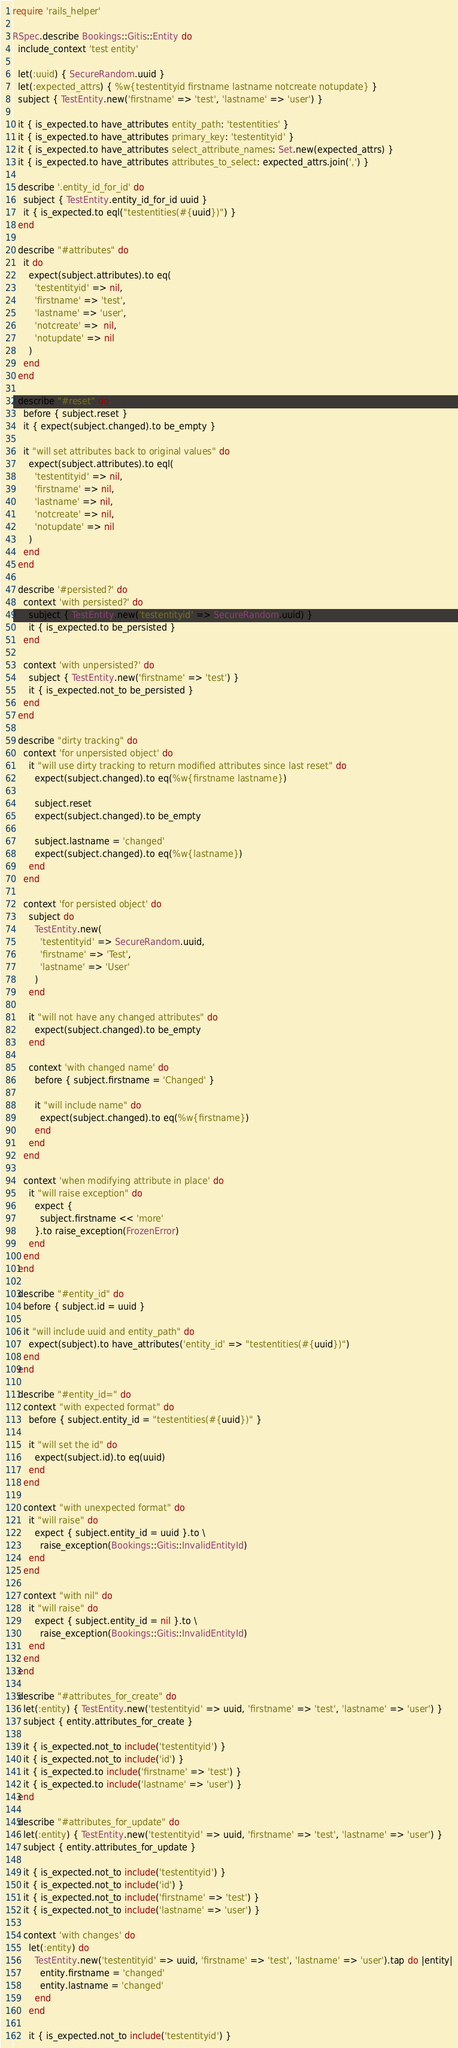Convert code to text. <code><loc_0><loc_0><loc_500><loc_500><_Ruby_>require 'rails_helper'

RSpec.describe Bookings::Gitis::Entity do
  include_context 'test entity'

  let(:uuid) { SecureRandom.uuid }
  let(:expected_attrs) { %w{testentityid firstname lastname notcreate notupdate} }
  subject { TestEntity.new('firstname' => 'test', 'lastname' => 'user') }

  it { is_expected.to have_attributes entity_path: 'testentities' }
  it { is_expected.to have_attributes primary_key: 'testentityid' }
  it { is_expected.to have_attributes select_attribute_names: Set.new(expected_attrs) }
  it { is_expected.to have_attributes attributes_to_select: expected_attrs.join(',') }

  describe '.entity_id_for_id' do
    subject { TestEntity.entity_id_for_id uuid }
    it { is_expected.to eql("testentities(#{uuid})") }
  end

  describe "#attributes" do
    it do
      expect(subject.attributes).to eq(
        'testentityid' => nil,
        'firstname' => 'test',
        'lastname' => 'user',
        'notcreate' =>  nil,
        'notupdate' => nil
      )
    end
  end

  describe "#reset" do
    before { subject.reset }
    it { expect(subject.changed).to be_empty }

    it "will set attributes back to original values" do
      expect(subject.attributes).to eql(
        'testentityid' => nil,
        'firstname' => nil,
        'lastname' => nil,
        'notcreate' => nil,
        'notupdate' => nil
      )
    end
  end

  describe '#persisted?' do
    context 'with persisted?' do
      subject { TestEntity.new('testentityid' => SecureRandom.uuid) }
      it { is_expected.to be_persisted }
    end

    context 'with unpersisted?' do
      subject { TestEntity.new('firstname' => 'test') }
      it { is_expected.not_to be_persisted }
    end
  end

  describe "dirty tracking" do
    context 'for unpersisted object' do
      it "will use dirty tracking to return modified attributes since last reset" do
        expect(subject.changed).to eq(%w{firstname lastname})

        subject.reset
        expect(subject.changed).to be_empty

        subject.lastname = 'changed'
        expect(subject.changed).to eq(%w{lastname})
      end
    end

    context 'for persisted object' do
      subject do
        TestEntity.new(
          'testentityid' => SecureRandom.uuid,
          'firstname' => 'Test',
          'lastname' => 'User'
        )
      end

      it "will not have any changed attributes" do
        expect(subject.changed).to be_empty
      end

      context 'with changed name' do
        before { subject.firstname = 'Changed' }

        it "will include name" do
          expect(subject.changed).to eq(%w{firstname})
        end
      end
    end

    context 'when modifying attribute in place' do
      it "will raise exception" do
        expect {
          subject.firstname << 'more'
        }.to raise_exception(FrozenError)
      end
    end
  end

  describe "#entity_id" do
    before { subject.id = uuid }

    it "will include uuid and entity_path" do
      expect(subject).to have_attributes('entity_id' => "testentities(#{uuid})")
    end
  end

  describe "#entity_id=" do
    context "with expected format" do
      before { subject.entity_id = "testentities(#{uuid})" }

      it "will set the id" do
        expect(subject.id).to eq(uuid)
      end
    end

    context "with unexpected format" do
      it "will raise" do
        expect { subject.entity_id = uuid }.to \
          raise_exception(Bookings::Gitis::InvalidEntityId)
      end
    end

    context "with nil" do
      it "will raise" do
        expect { subject.entity_id = nil }.to \
          raise_exception(Bookings::Gitis::InvalidEntityId)
      end
    end
  end

  describe "#attributes_for_create" do
    let(:entity) { TestEntity.new('testentityid' => uuid, 'firstname' => 'test', 'lastname' => 'user') }
    subject { entity.attributes_for_create }

    it { is_expected.not_to include('testentityid') }
    it { is_expected.not_to include('id') }
    it { is_expected.to include('firstname' => 'test') }
    it { is_expected.to include('lastname' => 'user') }
  end

  describe "#attributes_for_update" do
    let(:entity) { TestEntity.new('testentityid' => uuid, 'firstname' => 'test', 'lastname' => 'user') }
    subject { entity.attributes_for_update }

    it { is_expected.not_to include('testentityid') }
    it { is_expected.not_to include('id') }
    it { is_expected.not_to include('firstname' => 'test') }
    it { is_expected.not_to include('lastname' => 'user') }

    context 'with changes' do
      let(:entity) do
        TestEntity.new('testentityid' => uuid, 'firstname' => 'test', 'lastname' => 'user').tap do |entity|
          entity.firstname = 'changed'
          entity.lastname = 'changed'
        end
      end

      it { is_expected.not_to include('testentityid') }</code> 